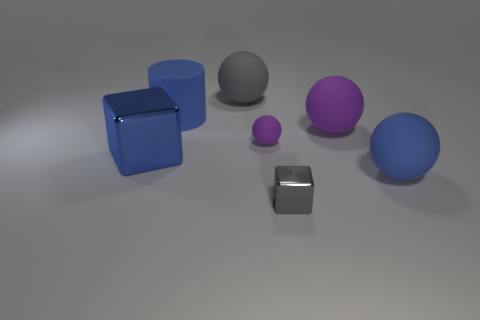There is a metallic block that is to the left of the gray object behind the gray shiny cube; what is its color?
Make the answer very short. Blue. There is a gray object that is in front of the large blue rubber object that is in front of the big object that is to the left of the matte cylinder; what is its size?
Ensure brevity in your answer.  Small. Is the tiny gray object made of the same material as the big object that is behind the cylinder?
Make the answer very short. No. What size is the other purple object that is the same material as the tiny purple object?
Your answer should be compact. Large. Is there a purple matte object of the same shape as the big blue metal thing?
Ensure brevity in your answer.  No. How many objects are either rubber spheres right of the tiny gray object or big blue blocks?
Offer a terse response. 3. What is the size of the rubber cylinder that is the same color as the big shiny cube?
Ensure brevity in your answer.  Large. There is a tiny object behind the large blue metal thing; is it the same color as the tiny thing in front of the tiny matte thing?
Offer a terse response. No. The blue shiny cube has what size?
Provide a succinct answer. Large. What number of tiny things are either rubber cylinders or balls?
Offer a very short reply. 1. 